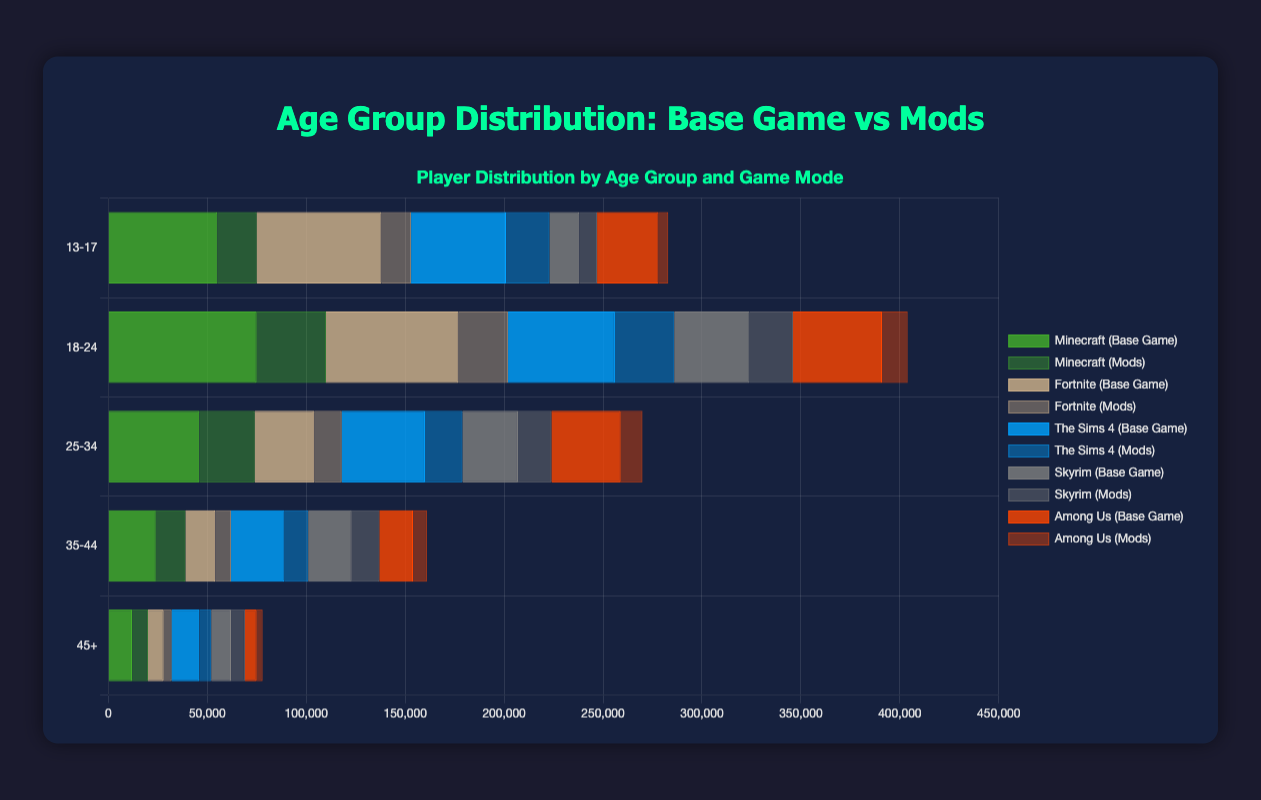Which age group has the highest number of players using mods for Minecraft? To find the answer, look at the bars representing "Minecraft (Mods)" for each age group and identify the tallest bar. The age group "18-24" has the highest number of players using mods for Minecraft with 35,000 players.
Answer: 18-24 How many total players play The Sims 4, combining both base game and mods, in the 35-44 age group? Add the number of players for The Sims 4 in the base game (27,000) and mods (12,000) in the 35-44 age group. The total is 27,000 + 12,000 = 39,000 players.
Answer: 39,000 Which game has more players in the 45+ age group, Among Us (Mods) or Skyrim (Mods)? Compare the heights of the bars for Among Us (Mods) and Skyrim (Mods) in the 45+ age group. Among Us (Mods) has 3,000 players, and Skyrim (Mods) has 7,000 players. Skyrim (Mods) has more players.
Answer: Skyrim In the 18-24 age group, what is the difference in the number of players between those playing Fortnite (Base Game) and those using mods? Subtract the number of players using mods (25,000) from those playing the base game (67,000) for Fortnite in the 18-24 age group. The difference is 67,000 - 25,000 = 42,000 players.
Answer: 42,000 Which age group has the most significant difference in the number of players for The Sims 4 between the base game and mods? Look at the differences between The Sims 4 base game and mods for each age group and find the highest value. For each age group: 13-17: 48,000 - 22,000 = 26,000; 18-24: 54,000 - 30,000 = 24,000; 25-34: 42,000 - 19,000 = 23,000; 35-44: 27,000 - 12,000 = 15,000; 45+: 14,000 - 6,000 = 8,000. Thus, the 13-17 age group has the most significant difference of 26,000 players.
Answer: 13-17 What's the total number of players aged 13-17 using mods across all games? Add up the number of players using mods for each game within the 13-17 age group. This is 20,000 (Minecraft) + 15,000 (Fortnite) + 22,000 (The Sims 4) + 9,000 (Skyrim) + 5,000 (Among Us) = 71,000 players.
Answer: 71,000 In the 25-34 age group, which game has the smallest number of mod users? Compare the bars representing mod users for Minecraft, Fortnite, The Sims 4, Skyrim, and Among Us in the 25-34 age group. Among Us (Mods) has the smallest number with 11,000 players.
Answer: Among Us What is the ratio of base game players to mod players for Skyrim in the 35-44 age group? The number of base game players for Skyrim in the 35-44 age group is 22,000, and for mods, it is 14,000. The ratio is 22,000 to 14,000, which simplifies to 22:14 or 11:7.
Answer: 11:7 